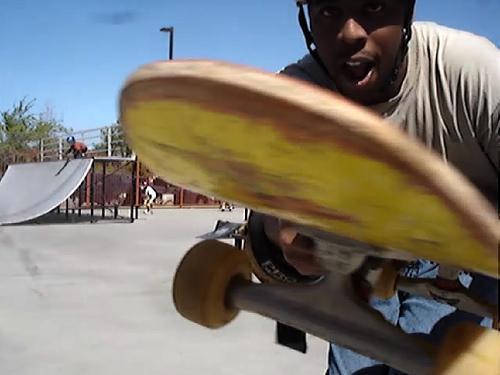How many ramps are visible?
Give a very brief answer. 1. How many semi trucks are in the mirror?
Give a very brief answer. 0. 